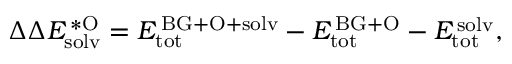Convert formula to latex. <formula><loc_0><loc_0><loc_500><loc_500>\Delta \Delta E _ { s o l v } ^ { \, * O } = E _ { t o t } ^ { \, B G + O + s o l v } - E _ { t o t } ^ { \, B G + O } - E _ { t o t } ^ { \, s o l v } ,</formula> 